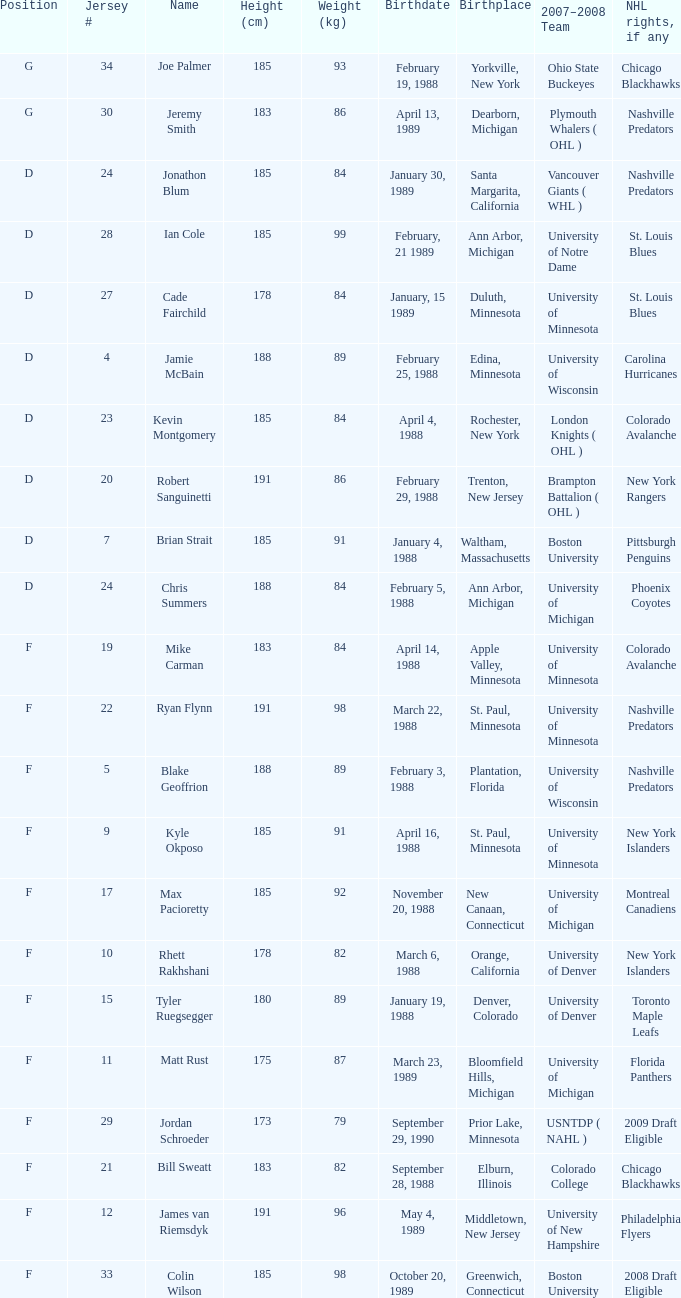Which Weight (kg) has a NHL rights, if any of phoenix coyotes? 1.0. 